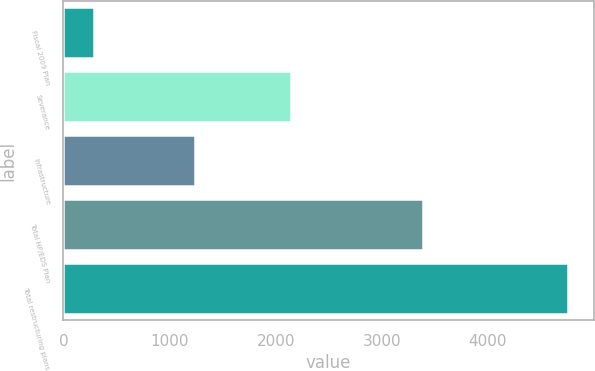Convert chart to OTSL. <chart><loc_0><loc_0><loc_500><loc_500><bar_chart><fcel>Fiscal 2009 Plan<fcel>Severance<fcel>Infrastructure<fcel>Total HP/EDS Plan<fcel>Total restructuring plans<nl><fcel>292<fcel>2146<fcel>1239<fcel>3385<fcel>4757<nl></chart> 